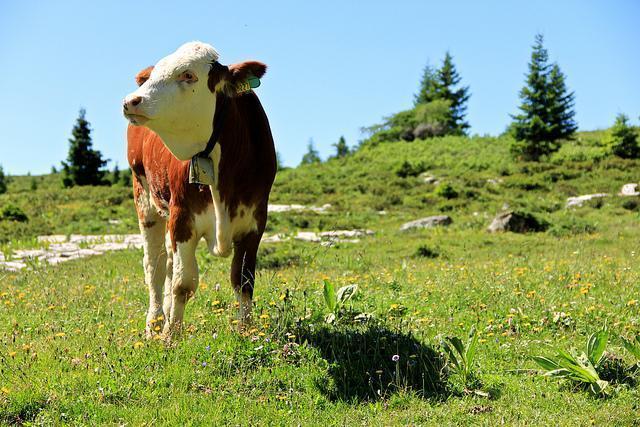How many people are on the couch?
Give a very brief answer. 0. 